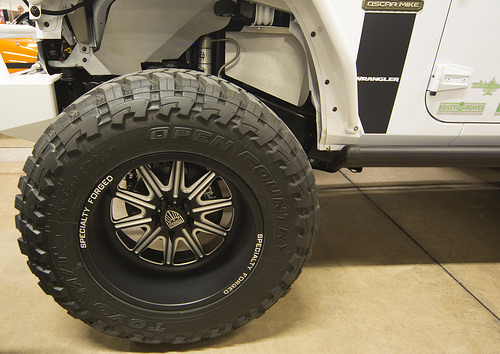<image>
Is the wheel on the truck? Yes. Looking at the image, I can see the wheel is positioned on top of the truck, with the truck providing support. Is there a rim to the left of the tire? No. The rim is not to the left of the tire. From this viewpoint, they have a different horizontal relationship. 